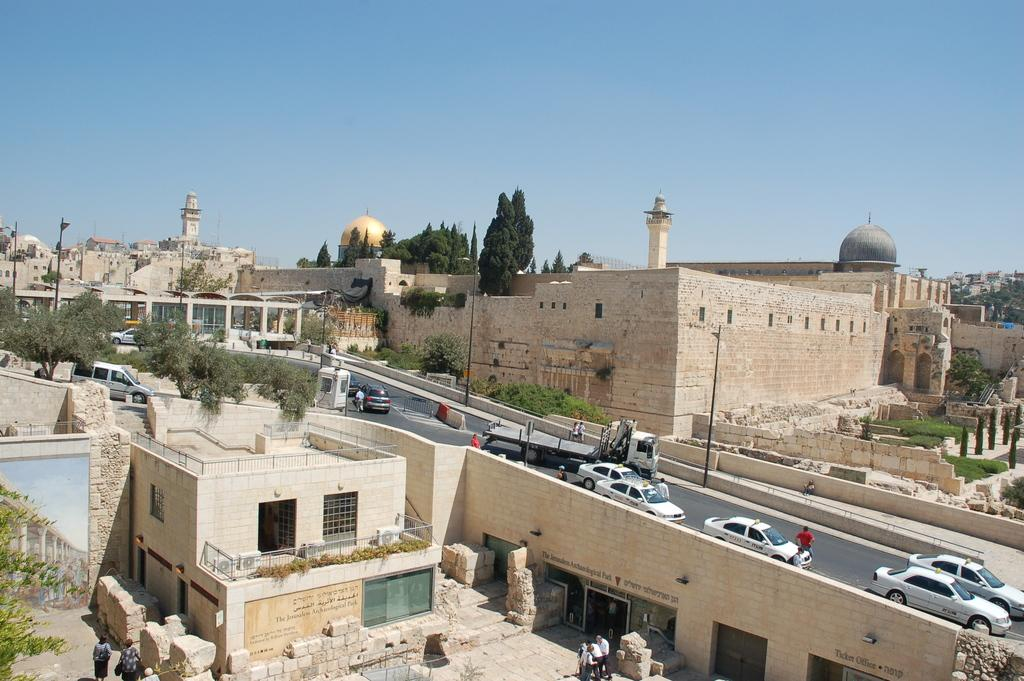What type of structures can be seen in the image? There are buildings in the image. What natural elements are present in the image? There are trees in the image. What man-made feature connects different areas in the image? There is a road and a bridge in the image. What vehicles can be seen in the image? There are cars in the image. What vertical structures are present in the image? There are poles in the image. What part of the natural environment is visible in the image? The sky is visible in the image. What verse is being recited by the fan in the image? There is no fan or verse present in the image. What type of conversation is happening between the cars in the image? There is no conversation happening between the cars in the image; they are stationary vehicles. 